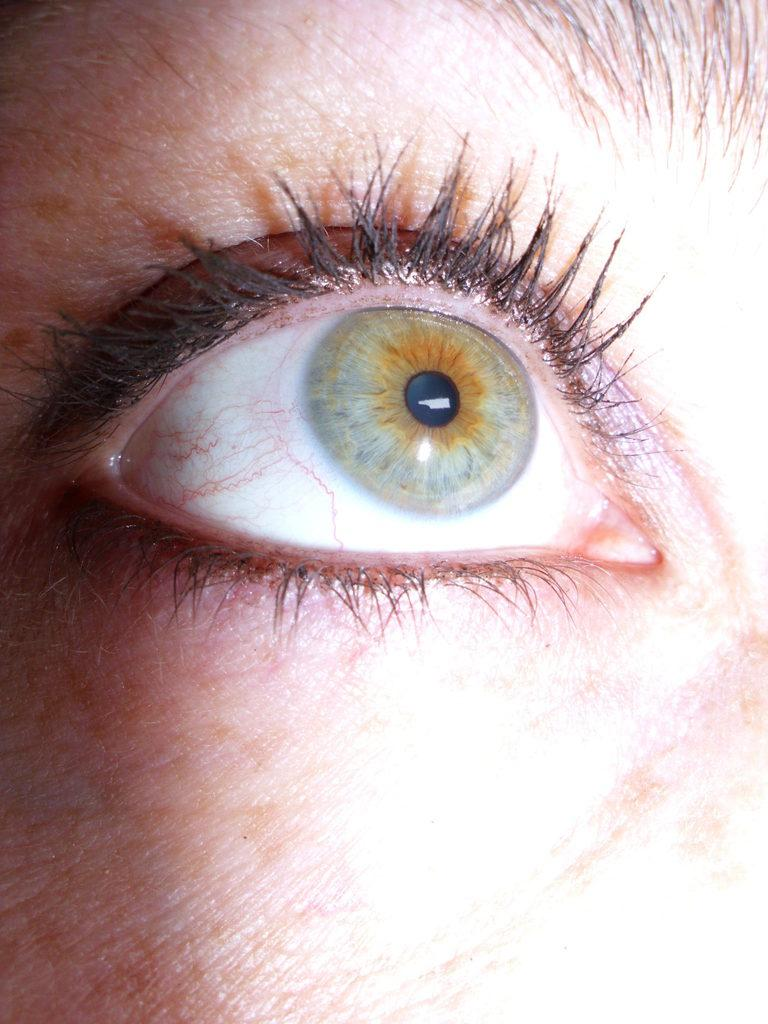What is the main subject of the image? The main subject of the image is an eye. Whose eye is it? The eye belongs to a person. What are some features of the eye in the image? Eyebrows and eyelids are present in the image. Can you see the river flowing behind the person's eye in the image? There is no river present in the image; it features a close-up of a person's eye with eyebrows and eyelids. 